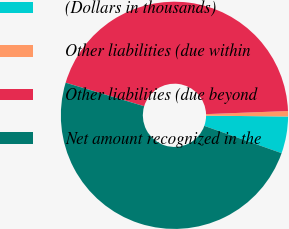<chart> <loc_0><loc_0><loc_500><loc_500><pie_chart><fcel>(Dollars in thousands)<fcel>Other liabilities (due within<fcel>Other liabilities (due beyond<fcel>Net amount recognized in the<nl><fcel>5.24%<fcel>0.77%<fcel>44.76%<fcel>49.23%<nl></chart> 